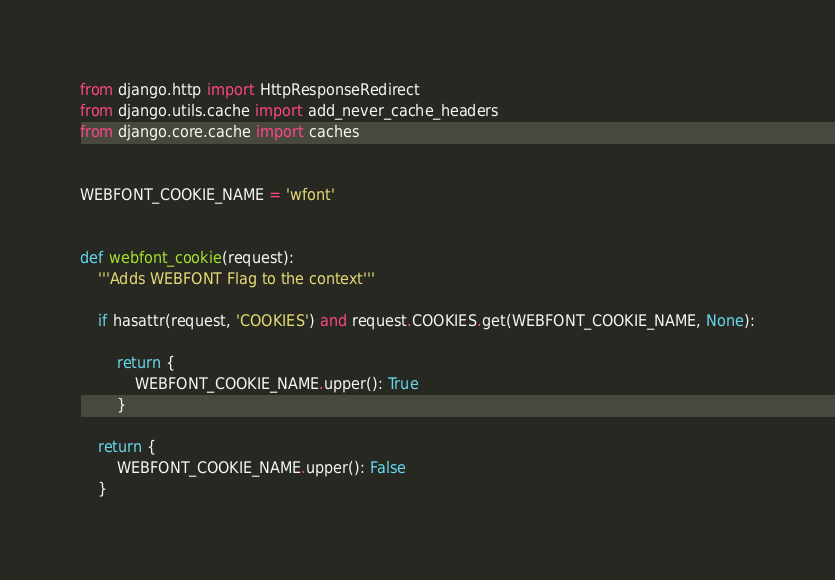Convert code to text. <code><loc_0><loc_0><loc_500><loc_500><_Python_>
from django.http import HttpResponseRedirect
from django.utils.cache import add_never_cache_headers
from django.core.cache import caches


WEBFONT_COOKIE_NAME = 'wfont'


def webfont_cookie(request):
    '''Adds WEBFONT Flag to the context'''

    if hasattr(request, 'COOKIES') and request.COOKIES.get(WEBFONT_COOKIE_NAME, None):

        return {
            WEBFONT_COOKIE_NAME.upper(): True
        }

    return {
        WEBFONT_COOKIE_NAME.upper(): False
    }
</code> 